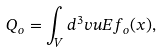Convert formula to latex. <formula><loc_0><loc_0><loc_500><loc_500>Q _ { o } = \int _ { V } d ^ { 3 } v u E f _ { o } ( x ) ,</formula> 